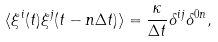Convert formula to latex. <formula><loc_0><loc_0><loc_500><loc_500>\langle \xi ^ { i } ( t ) \xi ^ { j } ( t - n \Delta t ) \rangle = \frac { \kappa } { \Delta t } \delta ^ { i j } \delta ^ { 0 n } ,</formula> 